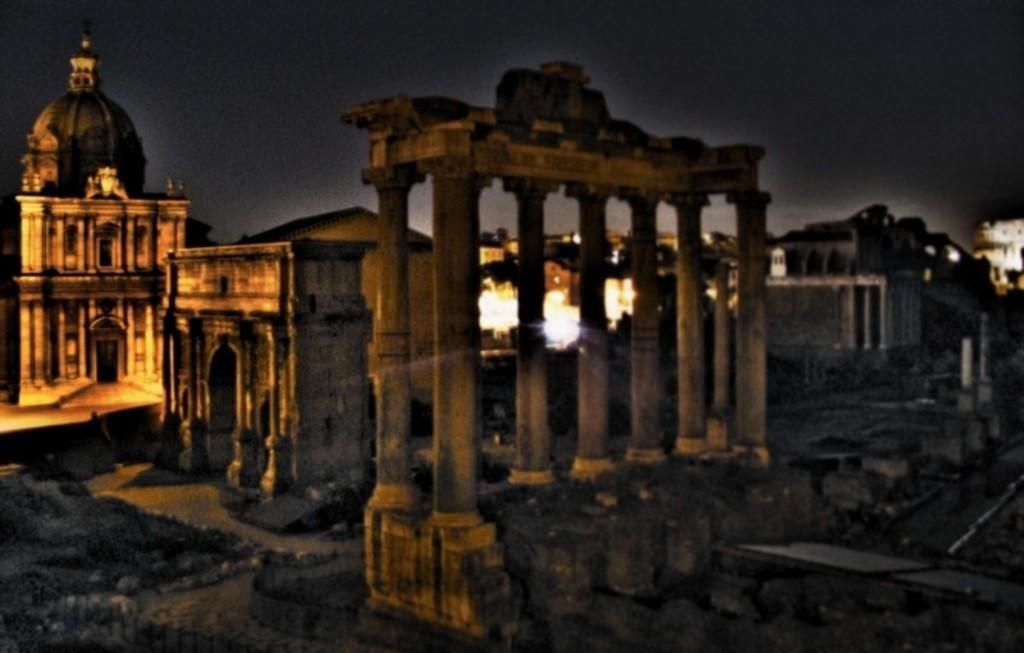How would you summarize this image in a sentence or two? In this image there are monuments and there are pillars. 